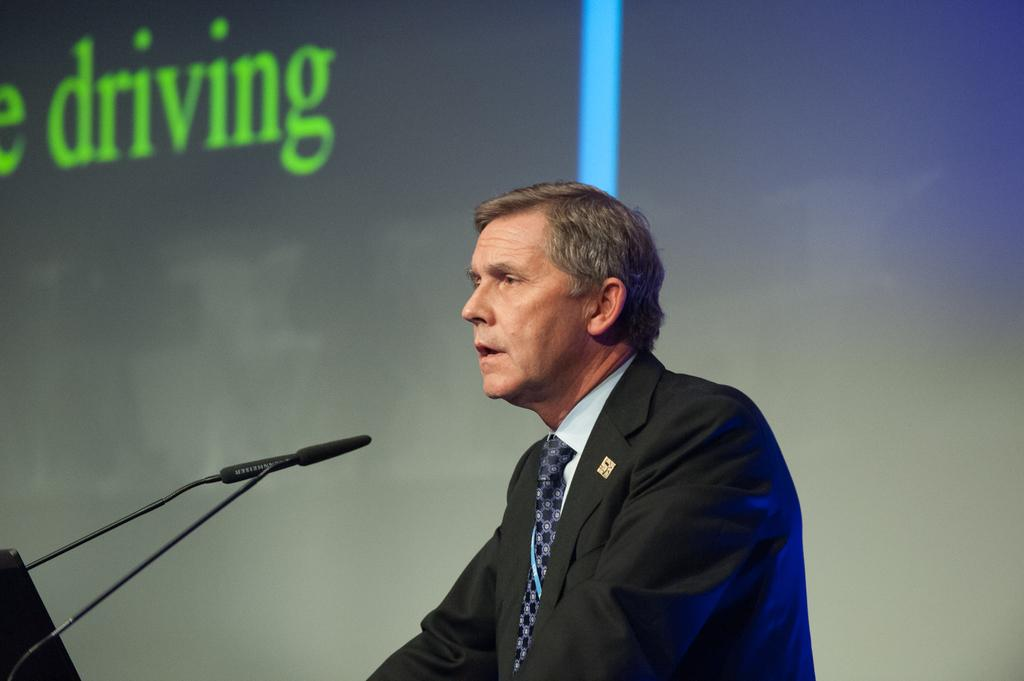What is the person in the image doing? The person is standing in front of a mic. What can be seen near the person in the image? There is a mic near the person in the image. What is visible in the background of the image? There is a screen with text visible in the background of the image. What type of thunder can be heard in the background of the image? There is no thunder present in the image; it is a still image with no sound. 